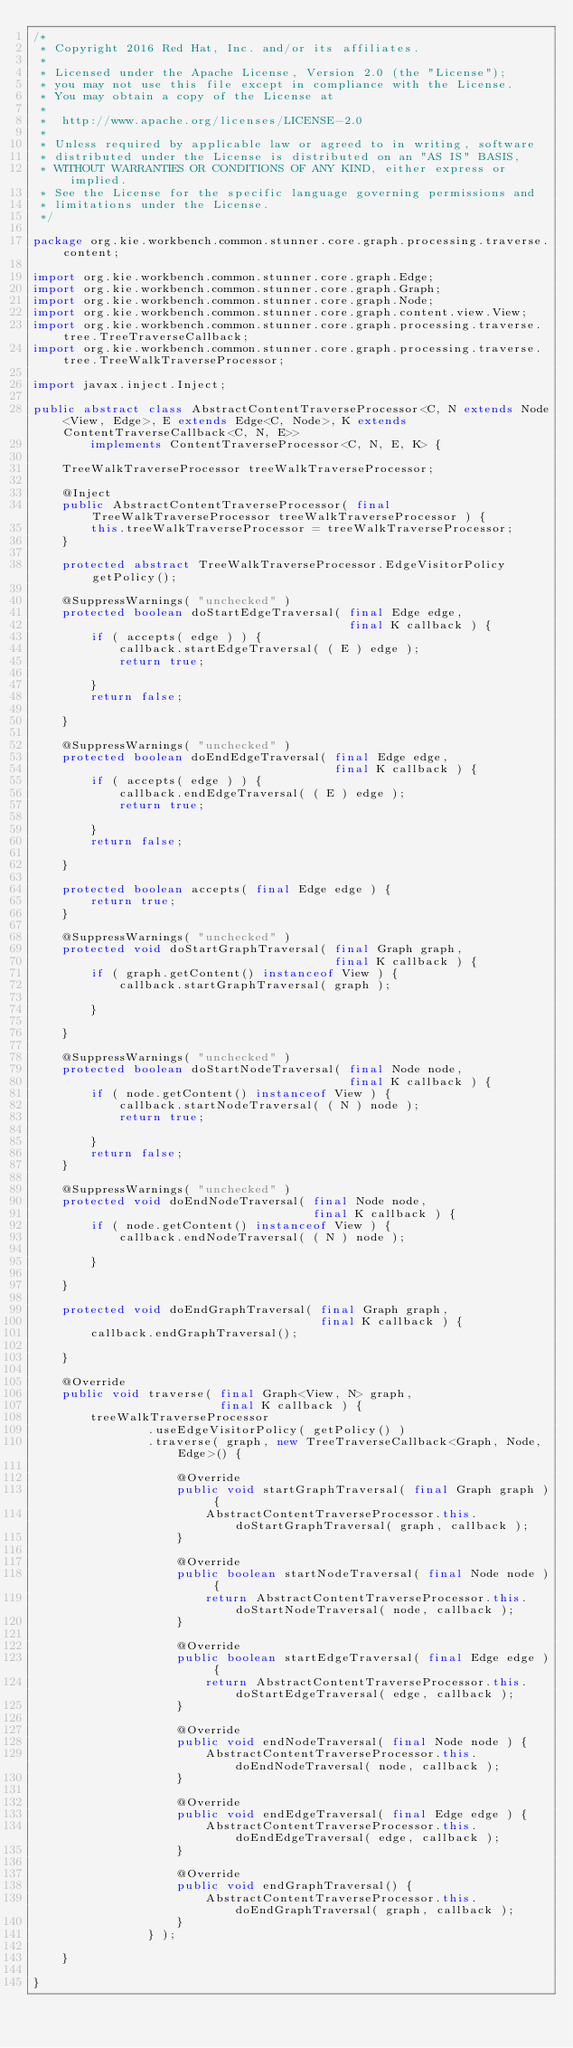<code> <loc_0><loc_0><loc_500><loc_500><_Java_>/*
 * Copyright 2016 Red Hat, Inc. and/or its affiliates.
 *
 * Licensed under the Apache License, Version 2.0 (the "License");
 * you may not use this file except in compliance with the License.
 * You may obtain a copy of the License at
 *
 * 	http://www.apache.org/licenses/LICENSE-2.0
 *
 * Unless required by applicable law or agreed to in writing, software
 * distributed under the License is distributed on an "AS IS" BASIS,
 * WITHOUT WARRANTIES OR CONDITIONS OF ANY KIND, either express or implied.
 * See the License for the specific language governing permissions and
 * limitations under the License.
 */

package org.kie.workbench.common.stunner.core.graph.processing.traverse.content;

import org.kie.workbench.common.stunner.core.graph.Edge;
import org.kie.workbench.common.stunner.core.graph.Graph;
import org.kie.workbench.common.stunner.core.graph.Node;
import org.kie.workbench.common.stunner.core.graph.content.view.View;
import org.kie.workbench.common.stunner.core.graph.processing.traverse.tree.TreeTraverseCallback;
import org.kie.workbench.common.stunner.core.graph.processing.traverse.tree.TreeWalkTraverseProcessor;

import javax.inject.Inject;

public abstract class AbstractContentTraverseProcessor<C, N extends Node<View, Edge>, E extends Edge<C, Node>, K extends ContentTraverseCallback<C, N, E>>
        implements ContentTraverseProcessor<C, N, E, K> {

    TreeWalkTraverseProcessor treeWalkTraverseProcessor;

    @Inject
    public AbstractContentTraverseProcessor( final TreeWalkTraverseProcessor treeWalkTraverseProcessor ) {
        this.treeWalkTraverseProcessor = treeWalkTraverseProcessor;
    }

    protected abstract TreeWalkTraverseProcessor.EdgeVisitorPolicy getPolicy();

    @SuppressWarnings( "unchecked" )
    protected boolean doStartEdgeTraversal( final Edge edge,
                                            final K callback ) {
        if ( accepts( edge ) ) {
            callback.startEdgeTraversal( ( E ) edge );
            return true;

        }
        return false;

    }

    @SuppressWarnings( "unchecked" )
    protected boolean doEndEdgeTraversal( final Edge edge,
                                          final K callback ) {
        if ( accepts( edge ) ) {
            callback.endEdgeTraversal( ( E ) edge );
            return true;

        }
        return false;

    }

    protected boolean accepts( final Edge edge ) {
        return true;
    }

    @SuppressWarnings( "unchecked" )
    protected void doStartGraphTraversal( final Graph graph,
                                          final K callback ) {
        if ( graph.getContent() instanceof View ) {
            callback.startGraphTraversal( graph );

        }

    }

    @SuppressWarnings( "unchecked" )
    protected boolean doStartNodeTraversal( final Node node,
                                            final K callback ) {
        if ( node.getContent() instanceof View ) {
            callback.startNodeTraversal( ( N ) node );
            return true;

        }
        return false;
    }

    @SuppressWarnings( "unchecked" )
    protected void doEndNodeTraversal( final Node node,
                                       final K callback ) {
        if ( node.getContent() instanceof View ) {
            callback.endNodeTraversal( ( N ) node );

        }

    }

    protected void doEndGraphTraversal( final Graph graph,
                                        final K callback ) {
        callback.endGraphTraversal();

    }

    @Override
    public void traverse( final Graph<View, N> graph,
                          final K callback ) {
        treeWalkTraverseProcessor
                .useEdgeVisitorPolicy( getPolicy() )
                .traverse( graph, new TreeTraverseCallback<Graph, Node, Edge>() {

                    @Override
                    public void startGraphTraversal( final Graph graph ) {
                        AbstractContentTraverseProcessor.this.doStartGraphTraversal( graph, callback );
                    }

                    @Override
                    public boolean startNodeTraversal( final Node node ) {
                        return AbstractContentTraverseProcessor.this.doStartNodeTraversal( node, callback );
                    }

                    @Override
                    public boolean startEdgeTraversal( final Edge edge ) {
                        return AbstractContentTraverseProcessor.this.doStartEdgeTraversal( edge, callback );
                    }

                    @Override
                    public void endNodeTraversal( final Node node ) {
                        AbstractContentTraverseProcessor.this.doEndNodeTraversal( node, callback );
                    }

                    @Override
                    public void endEdgeTraversal( final Edge edge ) {
                        AbstractContentTraverseProcessor.this.doEndEdgeTraversal( edge, callback );
                    }

                    @Override
                    public void endGraphTraversal() {
                        AbstractContentTraverseProcessor.this.doEndGraphTraversal( graph, callback );
                    }
                } );

    }

}
</code> 